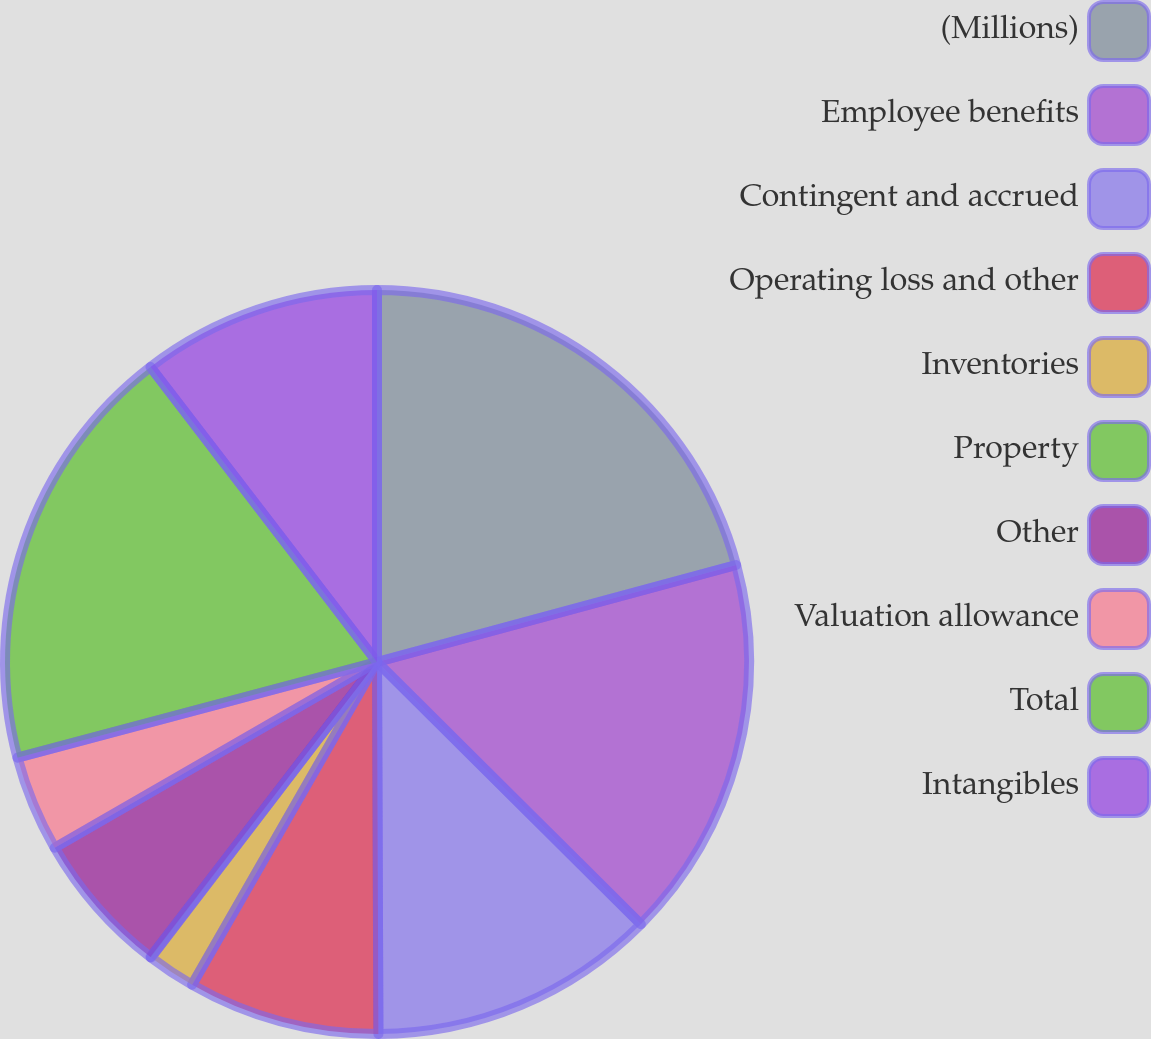Convert chart. <chart><loc_0><loc_0><loc_500><loc_500><pie_chart><fcel>(Millions)<fcel>Employee benefits<fcel>Contingent and accrued<fcel>Operating loss and other<fcel>Inventories<fcel>Property<fcel>Other<fcel>Valuation allowance<fcel>Total<fcel>Intangibles<nl><fcel>20.8%<fcel>16.65%<fcel>12.49%<fcel>8.34%<fcel>2.11%<fcel>0.03%<fcel>6.26%<fcel>4.18%<fcel>18.72%<fcel>10.42%<nl></chart> 